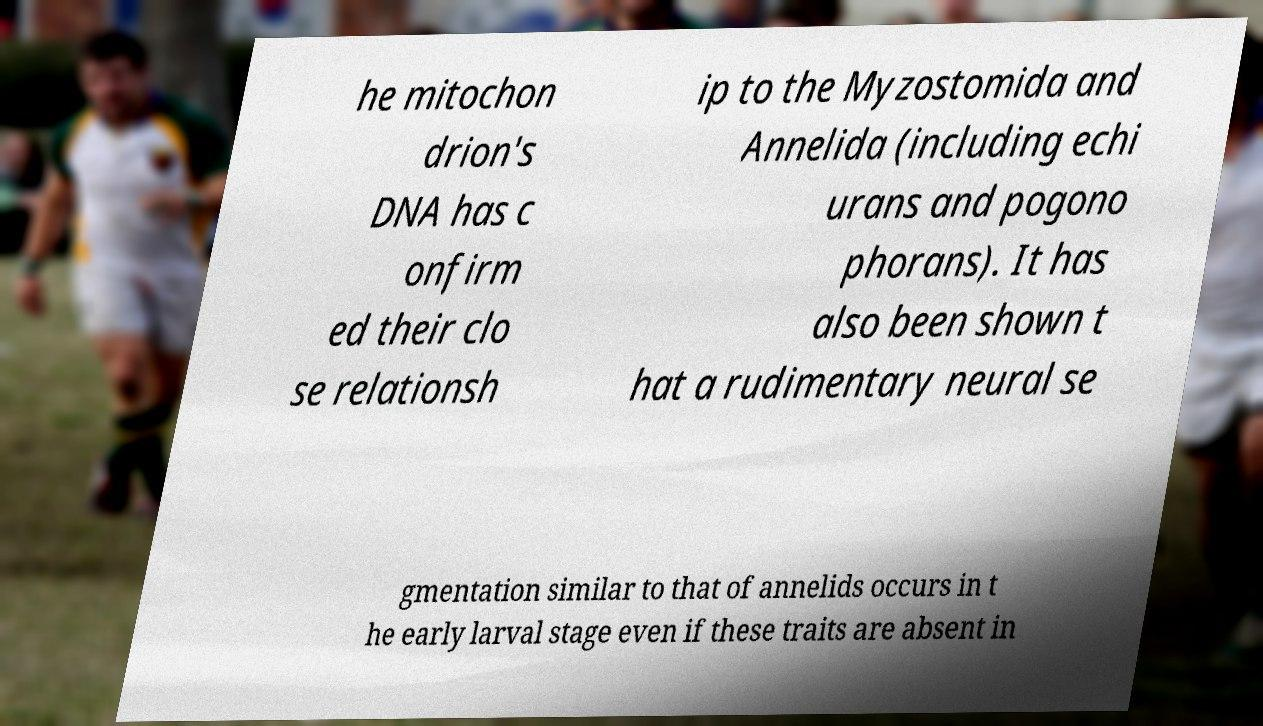Could you assist in decoding the text presented in this image and type it out clearly? he mitochon drion's DNA has c onfirm ed their clo se relationsh ip to the Myzostomida and Annelida (including echi urans and pogono phorans). It has also been shown t hat a rudimentary neural se gmentation similar to that of annelids occurs in t he early larval stage even if these traits are absent in 